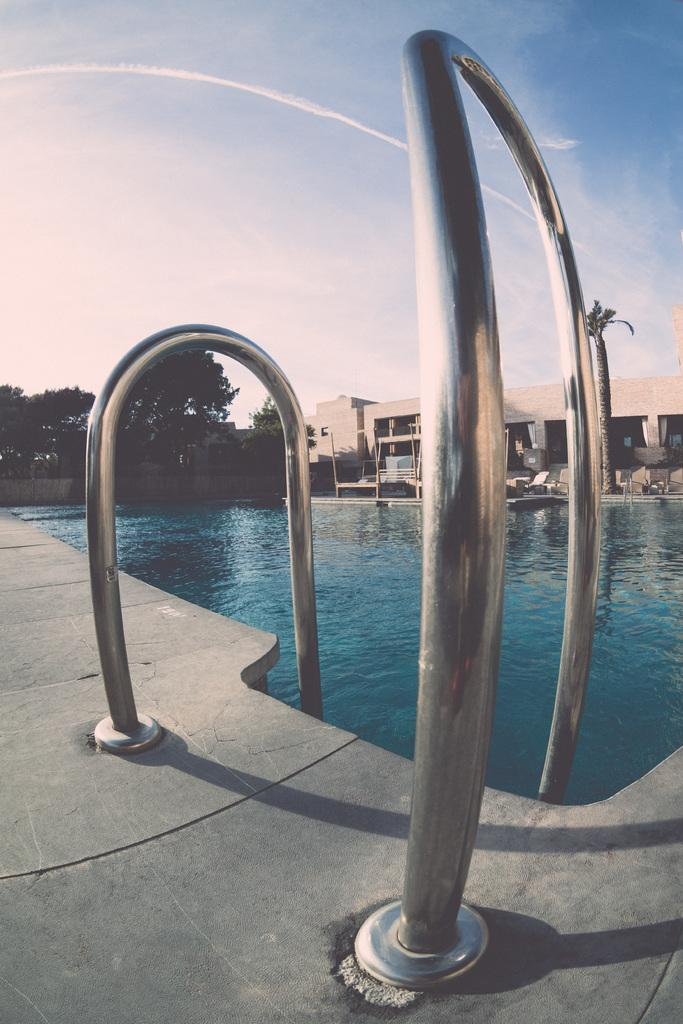What type of water feature is present in the image? There is a swimming pool in the image. What type of structure is visible in the image? There is a building in the image. What type of vegetation is present in the image? There are trees in the image. What is visible in the sky in the image? The sky is visible in the image, and clouds are present. How much payment is required to swim in the pool in the image? There is no information about payment or swimming in the image; it only shows a swimming pool, a building, trees, and the sky with clouds. What type of cannon is present in the image? There is no cannon present in the image. 